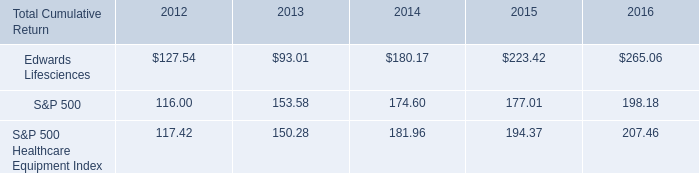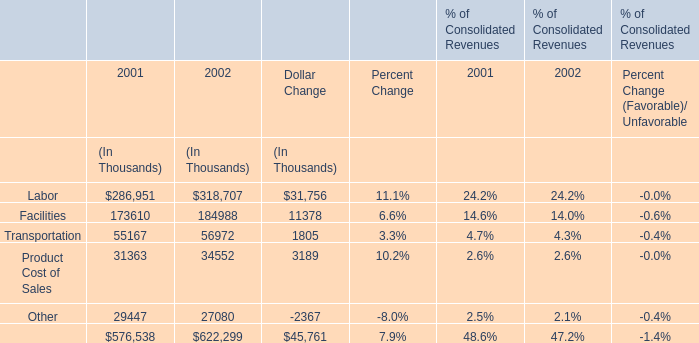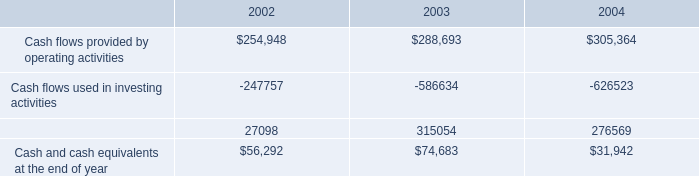what was the percentage cumulative total return for edwards lifesciences for the five years ended 2016? 
Computations: ((265.06 - 100) / 100)
Answer: 1.6506. 